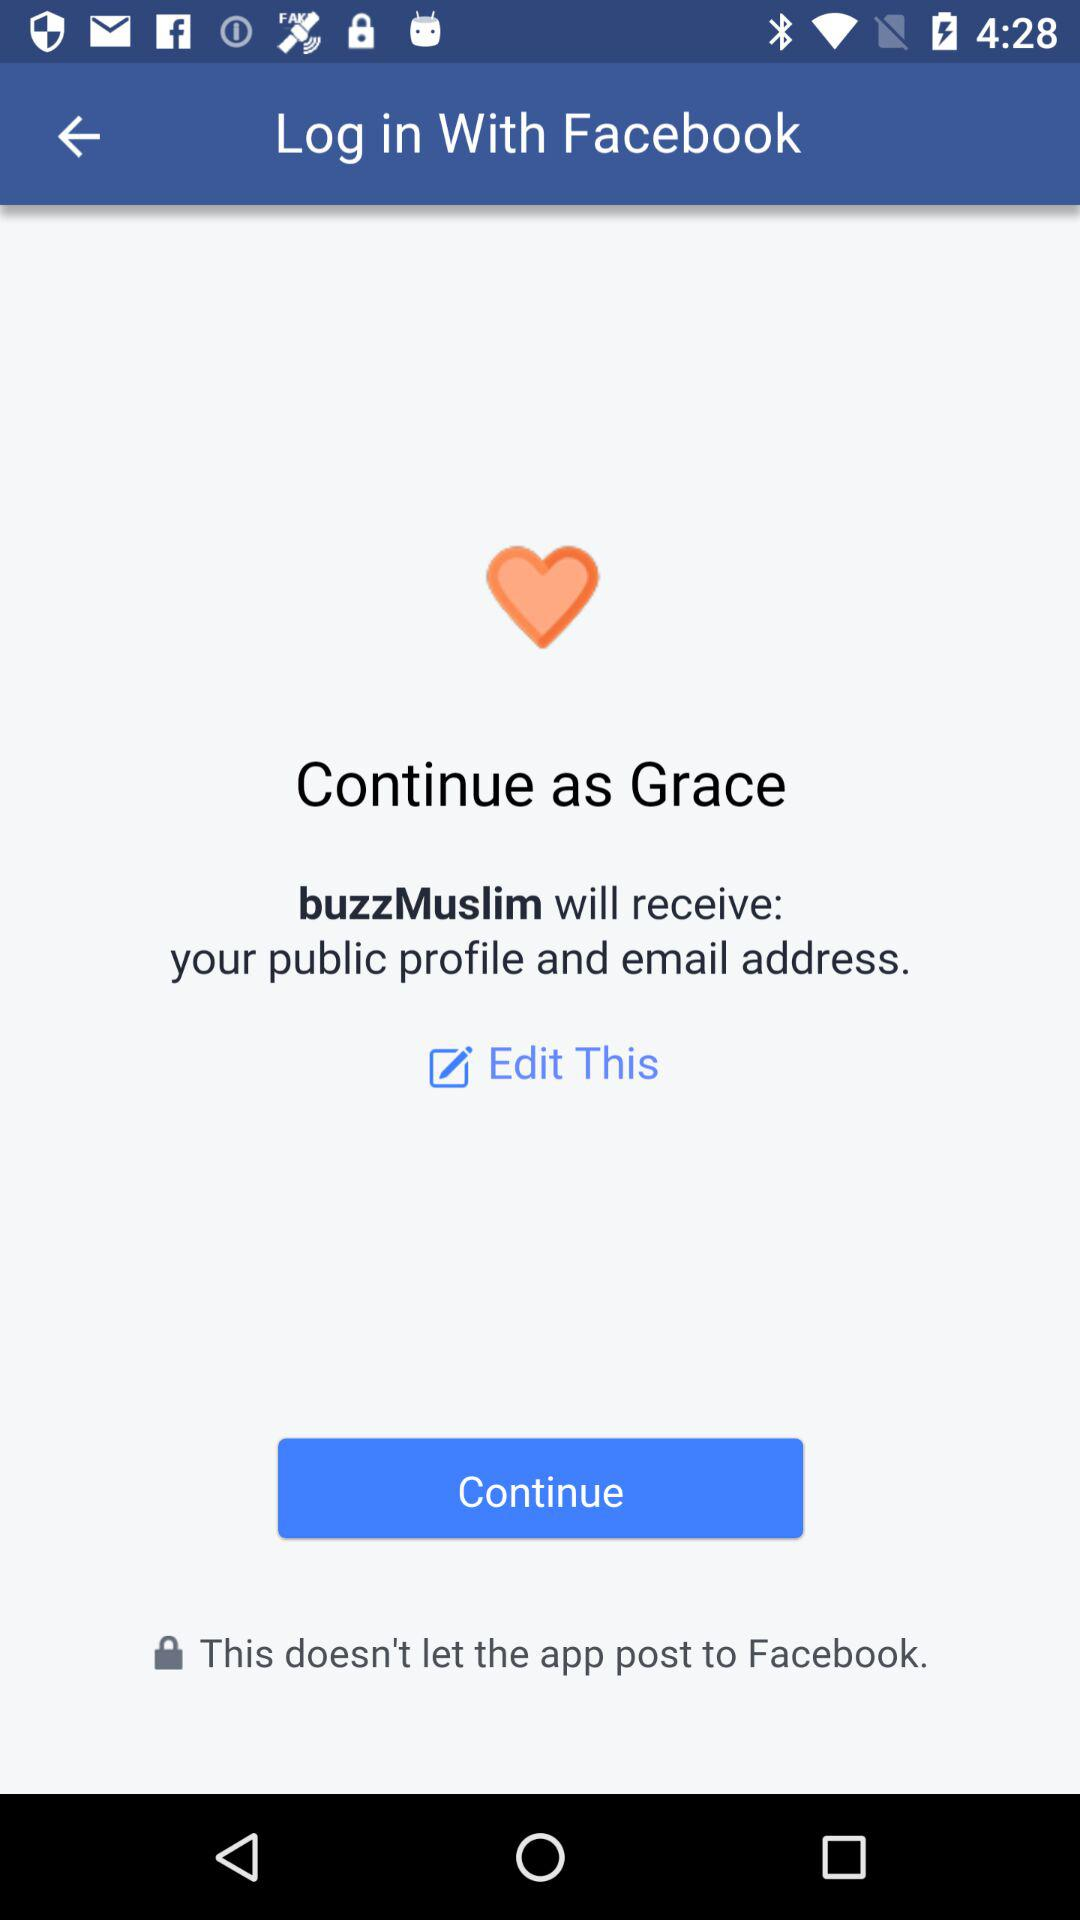What application will receive your public profile and email address? The application is "buzzMuslim". 